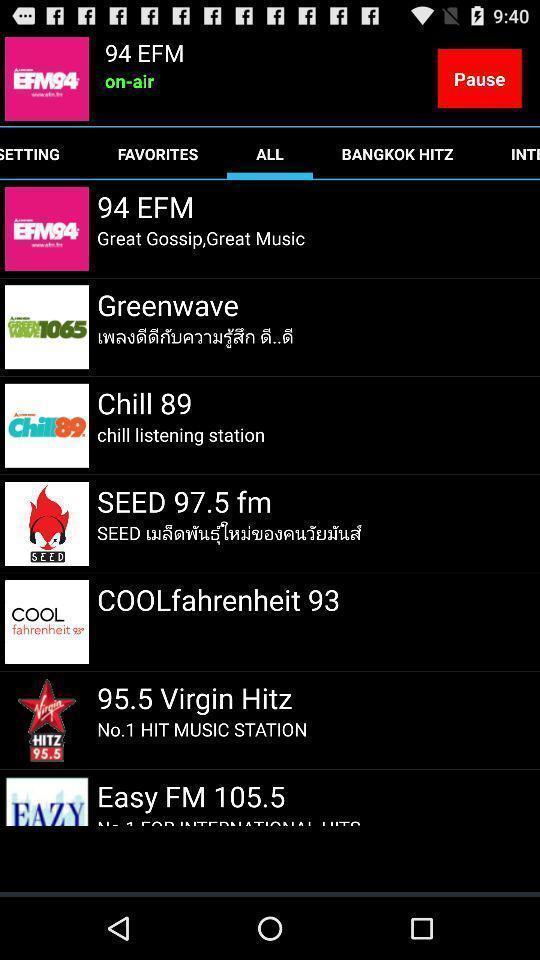Give me a narrative description of this picture. Page shows list of fm channels. 